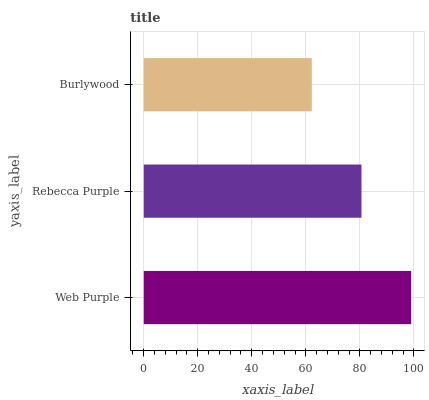Is Burlywood the minimum?
Answer yes or no. Yes. Is Web Purple the maximum?
Answer yes or no. Yes. Is Rebecca Purple the minimum?
Answer yes or no. No. Is Rebecca Purple the maximum?
Answer yes or no. No. Is Web Purple greater than Rebecca Purple?
Answer yes or no. Yes. Is Rebecca Purple less than Web Purple?
Answer yes or no. Yes. Is Rebecca Purple greater than Web Purple?
Answer yes or no. No. Is Web Purple less than Rebecca Purple?
Answer yes or no. No. Is Rebecca Purple the high median?
Answer yes or no. Yes. Is Rebecca Purple the low median?
Answer yes or no. Yes. Is Web Purple the high median?
Answer yes or no. No. Is Web Purple the low median?
Answer yes or no. No. 